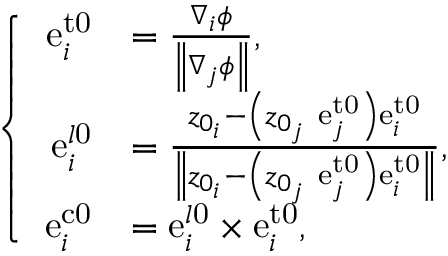<formula> <loc_0><loc_0><loc_500><loc_500>\left \{ \begin{array} { r l } { e _ { i } ^ { t 0 } } & { = \frac { \nabla _ { i } \phi } { \left \| \nabla _ { j } \phi \right \| } , } \\ { e _ { i } ^ { l 0 } } & { = \frac { z _ { 0 _ { i } } - \left ( z _ { 0 _ { j } } \ e _ { j } ^ { t 0 } \right ) e _ { i } ^ { t 0 } } { \left \| z _ { 0 _ { i } } - \left ( z _ { 0 _ { j } } \ e _ { j } ^ { t 0 } \right ) e _ { i } ^ { t 0 } \right \| } , } \\ { e _ { i } ^ { c 0 } } & { = e _ { i } ^ { l 0 } \times e _ { i } ^ { t 0 } , } \end{array}</formula> 